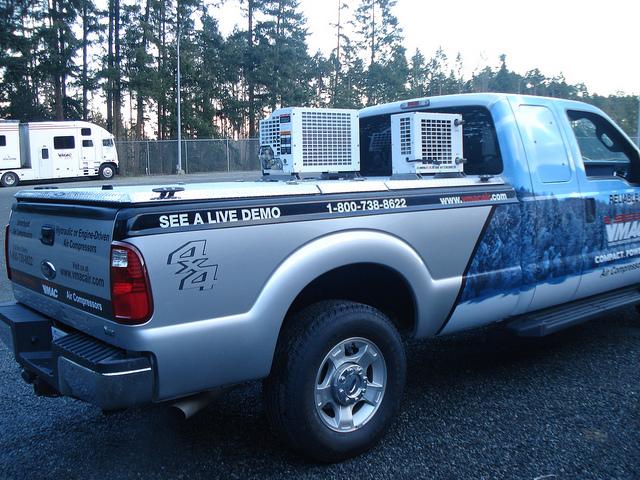What is on top of the truck?
Be succinct. Compressor. Which window on the truck is open?
Be succinct. Passenger. What is the phone number?
Keep it brief. 1-800-738-8622. What is the company name on the truck?
Concise answer only. Vma. Is this an old car?
Keep it brief. No. 